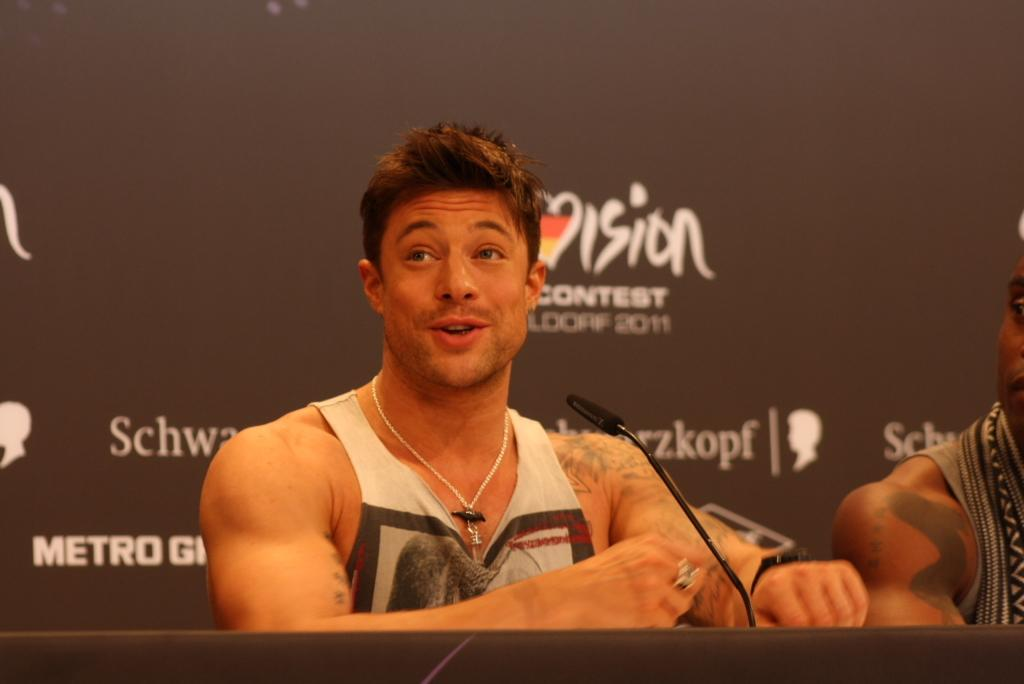How many people are present in the image? There are two persons sitting in the image. What object can be seen on the table? A: There is a microphone on the table. What can be seen in the background of the image? There is a board visible in the background of the image. What type of hobbies do the chickens have in the image? There are no chickens present in the image, so it is not possible to determine their hobbies. 